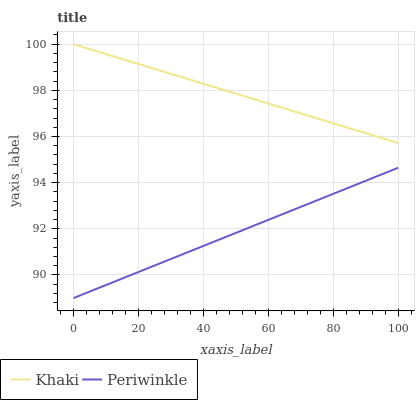Does Periwinkle have the minimum area under the curve?
Answer yes or no. Yes. Does Khaki have the maximum area under the curve?
Answer yes or no. Yes. Does Periwinkle have the maximum area under the curve?
Answer yes or no. No. Is Khaki the smoothest?
Answer yes or no. Yes. Is Periwinkle the roughest?
Answer yes or no. Yes. Is Periwinkle the smoothest?
Answer yes or no. No. Does Khaki have the highest value?
Answer yes or no. Yes. Does Periwinkle have the highest value?
Answer yes or no. No. Is Periwinkle less than Khaki?
Answer yes or no. Yes. Is Khaki greater than Periwinkle?
Answer yes or no. Yes. Does Periwinkle intersect Khaki?
Answer yes or no. No. 